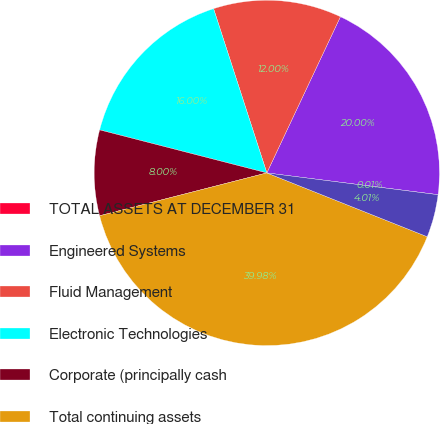Convert chart to OTSL. <chart><loc_0><loc_0><loc_500><loc_500><pie_chart><fcel>TOTAL ASSETS AT DECEMBER 31<fcel>Engineered Systems<fcel>Fluid Management<fcel>Electronic Technologies<fcel>Corporate (principally cash<fcel>Total continuing assets<fcel>Assets from discontinued<nl><fcel>0.01%<fcel>20.0%<fcel>12.0%<fcel>16.0%<fcel>8.0%<fcel>39.98%<fcel>4.01%<nl></chart> 